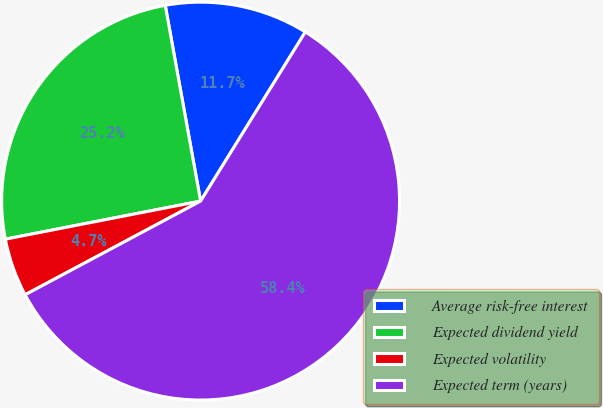Convert chart. <chart><loc_0><loc_0><loc_500><loc_500><pie_chart><fcel>Average risk-free interest<fcel>Expected dividend yield<fcel>Expected volatility<fcel>Expected term (years)<nl><fcel>11.67%<fcel>25.22%<fcel>4.74%<fcel>58.37%<nl></chart> 